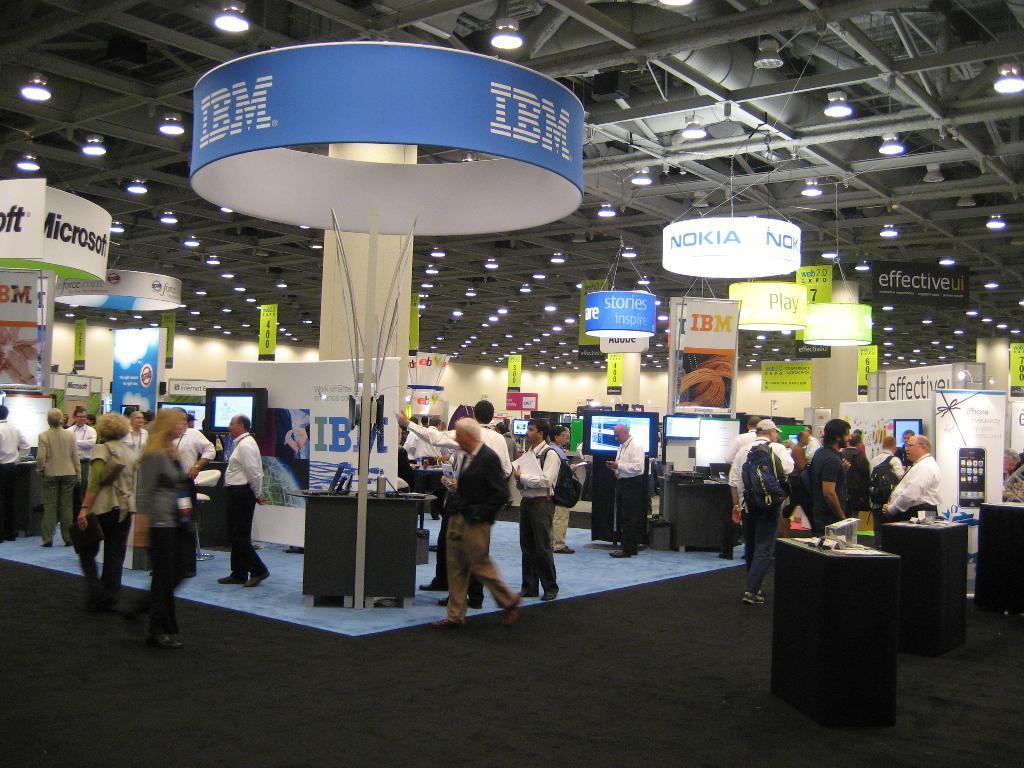Could you give a brief overview of what you see in this image? In this picture there are group of people and there are boards and there are screens and there is text on the boards and there are objects on the tables. At the top there are lights. At the bottom there is a mat on the floor. 